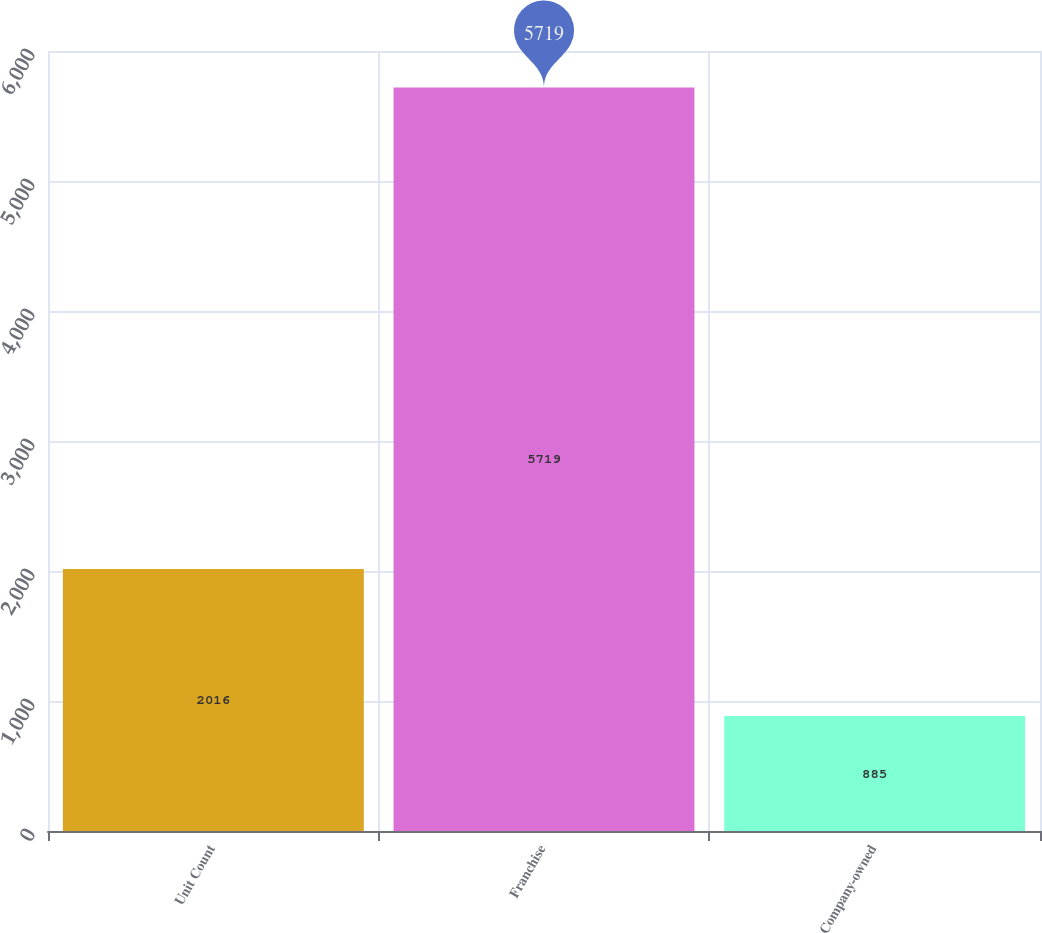Convert chart to OTSL. <chart><loc_0><loc_0><loc_500><loc_500><bar_chart><fcel>Unit Count<fcel>Franchise<fcel>Company-owned<nl><fcel>2016<fcel>5719<fcel>885<nl></chart> 